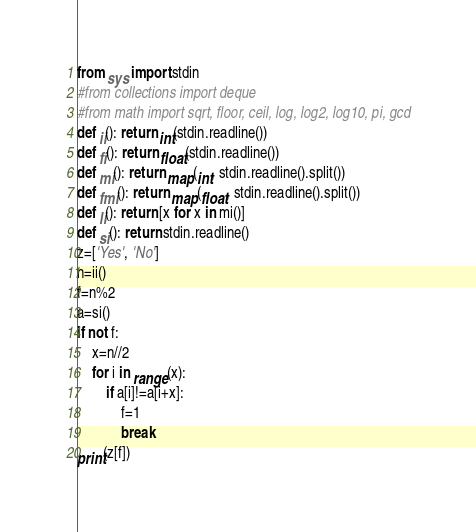<code> <loc_0><loc_0><loc_500><loc_500><_Python_>from sys import stdin
#from collections import deque
#from math import sqrt, floor, ceil, log, log2, log10, pi, gcd
def ii(): return int(stdin.readline())
def fi(): return float(stdin.readline())
def mi(): return map(int, stdin.readline().split())
def fmi(): return map(float, stdin.readline().split())
def li(): return [x for x in mi()]
def si(): return stdin.readline()
z=['Yes', 'No']
n=ii()
f=n%2
a=si()
if not f:
    x=n//2
    for i in range(x):
        if a[i]!=a[i+x]:
            f=1
            break
print(z[f])</code> 